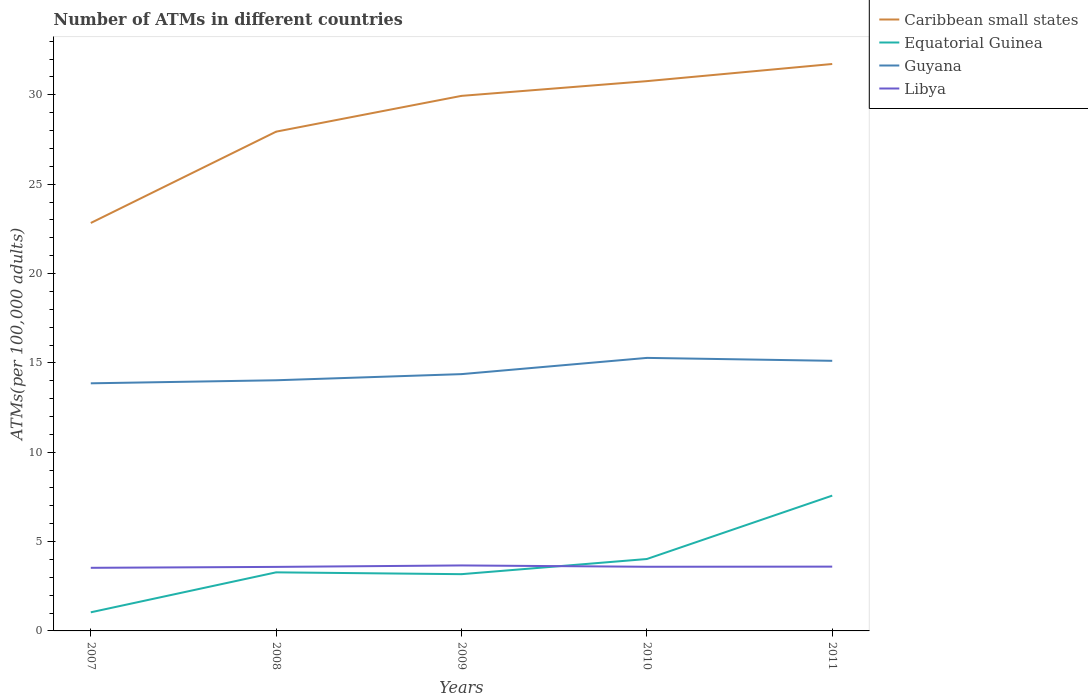How many different coloured lines are there?
Provide a short and direct response. 4. Is the number of lines equal to the number of legend labels?
Your answer should be compact. Yes. Across all years, what is the maximum number of ATMs in Caribbean small states?
Offer a terse response. 22.83. What is the total number of ATMs in Caribbean small states in the graph?
Your answer should be very brief. -8.9. What is the difference between the highest and the second highest number of ATMs in Guyana?
Keep it short and to the point. 1.42. What is the title of the graph?
Ensure brevity in your answer.  Number of ATMs in different countries. What is the label or title of the Y-axis?
Keep it short and to the point. ATMs(per 100,0 adults). What is the ATMs(per 100,000 adults) of Caribbean small states in 2007?
Ensure brevity in your answer.  22.83. What is the ATMs(per 100,000 adults) in Equatorial Guinea in 2007?
Give a very brief answer. 1.04. What is the ATMs(per 100,000 adults) in Guyana in 2007?
Offer a very short reply. 13.86. What is the ATMs(per 100,000 adults) in Libya in 2007?
Provide a short and direct response. 3.53. What is the ATMs(per 100,000 adults) of Caribbean small states in 2008?
Your answer should be very brief. 27.94. What is the ATMs(per 100,000 adults) of Equatorial Guinea in 2008?
Offer a very short reply. 3.28. What is the ATMs(per 100,000 adults) of Guyana in 2008?
Your answer should be very brief. 14.03. What is the ATMs(per 100,000 adults) of Libya in 2008?
Keep it short and to the point. 3.58. What is the ATMs(per 100,000 adults) in Caribbean small states in 2009?
Provide a succinct answer. 29.94. What is the ATMs(per 100,000 adults) in Equatorial Guinea in 2009?
Your answer should be very brief. 3.18. What is the ATMs(per 100,000 adults) in Guyana in 2009?
Your answer should be very brief. 14.37. What is the ATMs(per 100,000 adults) of Libya in 2009?
Ensure brevity in your answer.  3.66. What is the ATMs(per 100,000 adults) of Caribbean small states in 2010?
Provide a short and direct response. 30.77. What is the ATMs(per 100,000 adults) of Equatorial Guinea in 2010?
Make the answer very short. 4.02. What is the ATMs(per 100,000 adults) of Guyana in 2010?
Give a very brief answer. 15.28. What is the ATMs(per 100,000 adults) of Libya in 2010?
Provide a short and direct response. 3.59. What is the ATMs(per 100,000 adults) in Caribbean small states in 2011?
Your response must be concise. 31.73. What is the ATMs(per 100,000 adults) in Equatorial Guinea in 2011?
Your answer should be compact. 7.57. What is the ATMs(per 100,000 adults) of Guyana in 2011?
Give a very brief answer. 15.12. What is the ATMs(per 100,000 adults) of Libya in 2011?
Your answer should be compact. 3.6. Across all years, what is the maximum ATMs(per 100,000 adults) of Caribbean small states?
Provide a succinct answer. 31.73. Across all years, what is the maximum ATMs(per 100,000 adults) of Equatorial Guinea?
Ensure brevity in your answer.  7.57. Across all years, what is the maximum ATMs(per 100,000 adults) of Guyana?
Your answer should be very brief. 15.28. Across all years, what is the maximum ATMs(per 100,000 adults) of Libya?
Offer a terse response. 3.66. Across all years, what is the minimum ATMs(per 100,000 adults) of Caribbean small states?
Your answer should be very brief. 22.83. Across all years, what is the minimum ATMs(per 100,000 adults) of Equatorial Guinea?
Provide a succinct answer. 1.04. Across all years, what is the minimum ATMs(per 100,000 adults) in Guyana?
Keep it short and to the point. 13.86. Across all years, what is the minimum ATMs(per 100,000 adults) of Libya?
Your response must be concise. 3.53. What is the total ATMs(per 100,000 adults) in Caribbean small states in the graph?
Offer a very short reply. 143.21. What is the total ATMs(per 100,000 adults) in Equatorial Guinea in the graph?
Provide a succinct answer. 19.09. What is the total ATMs(per 100,000 adults) in Guyana in the graph?
Your answer should be compact. 72.65. What is the total ATMs(per 100,000 adults) of Libya in the graph?
Offer a very short reply. 17.97. What is the difference between the ATMs(per 100,000 adults) of Caribbean small states in 2007 and that in 2008?
Your response must be concise. -5.11. What is the difference between the ATMs(per 100,000 adults) in Equatorial Guinea in 2007 and that in 2008?
Your response must be concise. -2.24. What is the difference between the ATMs(per 100,000 adults) of Guyana in 2007 and that in 2008?
Offer a terse response. -0.17. What is the difference between the ATMs(per 100,000 adults) of Libya in 2007 and that in 2008?
Provide a succinct answer. -0.05. What is the difference between the ATMs(per 100,000 adults) in Caribbean small states in 2007 and that in 2009?
Provide a short and direct response. -7.11. What is the difference between the ATMs(per 100,000 adults) in Equatorial Guinea in 2007 and that in 2009?
Your answer should be compact. -2.13. What is the difference between the ATMs(per 100,000 adults) in Guyana in 2007 and that in 2009?
Make the answer very short. -0.51. What is the difference between the ATMs(per 100,000 adults) in Libya in 2007 and that in 2009?
Ensure brevity in your answer.  -0.13. What is the difference between the ATMs(per 100,000 adults) of Caribbean small states in 2007 and that in 2010?
Keep it short and to the point. -7.94. What is the difference between the ATMs(per 100,000 adults) of Equatorial Guinea in 2007 and that in 2010?
Offer a very short reply. -2.98. What is the difference between the ATMs(per 100,000 adults) in Guyana in 2007 and that in 2010?
Provide a succinct answer. -1.42. What is the difference between the ATMs(per 100,000 adults) in Libya in 2007 and that in 2010?
Provide a succinct answer. -0.06. What is the difference between the ATMs(per 100,000 adults) in Caribbean small states in 2007 and that in 2011?
Your response must be concise. -8.9. What is the difference between the ATMs(per 100,000 adults) of Equatorial Guinea in 2007 and that in 2011?
Give a very brief answer. -6.53. What is the difference between the ATMs(per 100,000 adults) in Guyana in 2007 and that in 2011?
Keep it short and to the point. -1.26. What is the difference between the ATMs(per 100,000 adults) in Libya in 2007 and that in 2011?
Your answer should be compact. -0.07. What is the difference between the ATMs(per 100,000 adults) of Caribbean small states in 2008 and that in 2009?
Your answer should be very brief. -2. What is the difference between the ATMs(per 100,000 adults) of Equatorial Guinea in 2008 and that in 2009?
Offer a very short reply. 0.1. What is the difference between the ATMs(per 100,000 adults) of Guyana in 2008 and that in 2009?
Offer a very short reply. -0.34. What is the difference between the ATMs(per 100,000 adults) in Libya in 2008 and that in 2009?
Your answer should be very brief. -0.08. What is the difference between the ATMs(per 100,000 adults) in Caribbean small states in 2008 and that in 2010?
Ensure brevity in your answer.  -2.83. What is the difference between the ATMs(per 100,000 adults) of Equatorial Guinea in 2008 and that in 2010?
Offer a very short reply. -0.75. What is the difference between the ATMs(per 100,000 adults) of Guyana in 2008 and that in 2010?
Provide a short and direct response. -1.25. What is the difference between the ATMs(per 100,000 adults) in Libya in 2008 and that in 2010?
Ensure brevity in your answer.  -0.01. What is the difference between the ATMs(per 100,000 adults) of Caribbean small states in 2008 and that in 2011?
Offer a terse response. -3.79. What is the difference between the ATMs(per 100,000 adults) in Equatorial Guinea in 2008 and that in 2011?
Ensure brevity in your answer.  -4.29. What is the difference between the ATMs(per 100,000 adults) of Guyana in 2008 and that in 2011?
Give a very brief answer. -1.09. What is the difference between the ATMs(per 100,000 adults) in Libya in 2008 and that in 2011?
Keep it short and to the point. -0.01. What is the difference between the ATMs(per 100,000 adults) in Caribbean small states in 2009 and that in 2010?
Your answer should be very brief. -0.82. What is the difference between the ATMs(per 100,000 adults) of Equatorial Guinea in 2009 and that in 2010?
Make the answer very short. -0.85. What is the difference between the ATMs(per 100,000 adults) of Guyana in 2009 and that in 2010?
Your answer should be very brief. -0.91. What is the difference between the ATMs(per 100,000 adults) of Libya in 2009 and that in 2010?
Offer a very short reply. 0.07. What is the difference between the ATMs(per 100,000 adults) of Caribbean small states in 2009 and that in 2011?
Ensure brevity in your answer.  -1.78. What is the difference between the ATMs(per 100,000 adults) in Equatorial Guinea in 2009 and that in 2011?
Provide a succinct answer. -4.4. What is the difference between the ATMs(per 100,000 adults) of Guyana in 2009 and that in 2011?
Your response must be concise. -0.75. What is the difference between the ATMs(per 100,000 adults) of Libya in 2009 and that in 2011?
Offer a very short reply. 0.07. What is the difference between the ATMs(per 100,000 adults) of Caribbean small states in 2010 and that in 2011?
Ensure brevity in your answer.  -0.96. What is the difference between the ATMs(per 100,000 adults) of Equatorial Guinea in 2010 and that in 2011?
Your response must be concise. -3.55. What is the difference between the ATMs(per 100,000 adults) in Guyana in 2010 and that in 2011?
Provide a short and direct response. 0.16. What is the difference between the ATMs(per 100,000 adults) of Libya in 2010 and that in 2011?
Your response must be concise. -0.01. What is the difference between the ATMs(per 100,000 adults) of Caribbean small states in 2007 and the ATMs(per 100,000 adults) of Equatorial Guinea in 2008?
Your answer should be very brief. 19.55. What is the difference between the ATMs(per 100,000 adults) of Caribbean small states in 2007 and the ATMs(per 100,000 adults) of Guyana in 2008?
Ensure brevity in your answer.  8.8. What is the difference between the ATMs(per 100,000 adults) of Caribbean small states in 2007 and the ATMs(per 100,000 adults) of Libya in 2008?
Make the answer very short. 19.25. What is the difference between the ATMs(per 100,000 adults) of Equatorial Guinea in 2007 and the ATMs(per 100,000 adults) of Guyana in 2008?
Provide a succinct answer. -12.99. What is the difference between the ATMs(per 100,000 adults) in Equatorial Guinea in 2007 and the ATMs(per 100,000 adults) in Libya in 2008?
Offer a terse response. -2.54. What is the difference between the ATMs(per 100,000 adults) in Guyana in 2007 and the ATMs(per 100,000 adults) in Libya in 2008?
Your answer should be very brief. 10.27. What is the difference between the ATMs(per 100,000 adults) in Caribbean small states in 2007 and the ATMs(per 100,000 adults) in Equatorial Guinea in 2009?
Offer a very short reply. 19.65. What is the difference between the ATMs(per 100,000 adults) in Caribbean small states in 2007 and the ATMs(per 100,000 adults) in Guyana in 2009?
Provide a short and direct response. 8.46. What is the difference between the ATMs(per 100,000 adults) in Caribbean small states in 2007 and the ATMs(per 100,000 adults) in Libya in 2009?
Keep it short and to the point. 19.16. What is the difference between the ATMs(per 100,000 adults) of Equatorial Guinea in 2007 and the ATMs(per 100,000 adults) of Guyana in 2009?
Offer a very short reply. -13.33. What is the difference between the ATMs(per 100,000 adults) of Equatorial Guinea in 2007 and the ATMs(per 100,000 adults) of Libya in 2009?
Offer a terse response. -2.62. What is the difference between the ATMs(per 100,000 adults) of Guyana in 2007 and the ATMs(per 100,000 adults) of Libya in 2009?
Make the answer very short. 10.19. What is the difference between the ATMs(per 100,000 adults) in Caribbean small states in 2007 and the ATMs(per 100,000 adults) in Equatorial Guinea in 2010?
Ensure brevity in your answer.  18.8. What is the difference between the ATMs(per 100,000 adults) of Caribbean small states in 2007 and the ATMs(per 100,000 adults) of Guyana in 2010?
Keep it short and to the point. 7.55. What is the difference between the ATMs(per 100,000 adults) of Caribbean small states in 2007 and the ATMs(per 100,000 adults) of Libya in 2010?
Offer a very short reply. 19.24. What is the difference between the ATMs(per 100,000 adults) in Equatorial Guinea in 2007 and the ATMs(per 100,000 adults) in Guyana in 2010?
Provide a succinct answer. -14.24. What is the difference between the ATMs(per 100,000 adults) of Equatorial Guinea in 2007 and the ATMs(per 100,000 adults) of Libya in 2010?
Offer a terse response. -2.55. What is the difference between the ATMs(per 100,000 adults) in Guyana in 2007 and the ATMs(per 100,000 adults) in Libya in 2010?
Keep it short and to the point. 10.27. What is the difference between the ATMs(per 100,000 adults) in Caribbean small states in 2007 and the ATMs(per 100,000 adults) in Equatorial Guinea in 2011?
Offer a very short reply. 15.26. What is the difference between the ATMs(per 100,000 adults) in Caribbean small states in 2007 and the ATMs(per 100,000 adults) in Guyana in 2011?
Your answer should be compact. 7.71. What is the difference between the ATMs(per 100,000 adults) of Caribbean small states in 2007 and the ATMs(per 100,000 adults) of Libya in 2011?
Give a very brief answer. 19.23. What is the difference between the ATMs(per 100,000 adults) in Equatorial Guinea in 2007 and the ATMs(per 100,000 adults) in Guyana in 2011?
Your response must be concise. -14.07. What is the difference between the ATMs(per 100,000 adults) in Equatorial Guinea in 2007 and the ATMs(per 100,000 adults) in Libya in 2011?
Your answer should be compact. -2.56. What is the difference between the ATMs(per 100,000 adults) of Guyana in 2007 and the ATMs(per 100,000 adults) of Libya in 2011?
Your answer should be compact. 10.26. What is the difference between the ATMs(per 100,000 adults) in Caribbean small states in 2008 and the ATMs(per 100,000 adults) in Equatorial Guinea in 2009?
Provide a short and direct response. 24.76. What is the difference between the ATMs(per 100,000 adults) in Caribbean small states in 2008 and the ATMs(per 100,000 adults) in Guyana in 2009?
Offer a terse response. 13.57. What is the difference between the ATMs(per 100,000 adults) in Caribbean small states in 2008 and the ATMs(per 100,000 adults) in Libya in 2009?
Provide a succinct answer. 24.28. What is the difference between the ATMs(per 100,000 adults) in Equatorial Guinea in 2008 and the ATMs(per 100,000 adults) in Guyana in 2009?
Ensure brevity in your answer.  -11.09. What is the difference between the ATMs(per 100,000 adults) of Equatorial Guinea in 2008 and the ATMs(per 100,000 adults) of Libya in 2009?
Make the answer very short. -0.39. What is the difference between the ATMs(per 100,000 adults) in Guyana in 2008 and the ATMs(per 100,000 adults) in Libya in 2009?
Make the answer very short. 10.36. What is the difference between the ATMs(per 100,000 adults) in Caribbean small states in 2008 and the ATMs(per 100,000 adults) in Equatorial Guinea in 2010?
Provide a short and direct response. 23.92. What is the difference between the ATMs(per 100,000 adults) in Caribbean small states in 2008 and the ATMs(per 100,000 adults) in Guyana in 2010?
Provide a short and direct response. 12.66. What is the difference between the ATMs(per 100,000 adults) of Caribbean small states in 2008 and the ATMs(per 100,000 adults) of Libya in 2010?
Your answer should be very brief. 24.35. What is the difference between the ATMs(per 100,000 adults) of Equatorial Guinea in 2008 and the ATMs(per 100,000 adults) of Guyana in 2010?
Give a very brief answer. -12. What is the difference between the ATMs(per 100,000 adults) in Equatorial Guinea in 2008 and the ATMs(per 100,000 adults) in Libya in 2010?
Offer a terse response. -0.31. What is the difference between the ATMs(per 100,000 adults) of Guyana in 2008 and the ATMs(per 100,000 adults) of Libya in 2010?
Give a very brief answer. 10.44. What is the difference between the ATMs(per 100,000 adults) in Caribbean small states in 2008 and the ATMs(per 100,000 adults) in Equatorial Guinea in 2011?
Your answer should be very brief. 20.37. What is the difference between the ATMs(per 100,000 adults) in Caribbean small states in 2008 and the ATMs(per 100,000 adults) in Guyana in 2011?
Keep it short and to the point. 12.82. What is the difference between the ATMs(per 100,000 adults) of Caribbean small states in 2008 and the ATMs(per 100,000 adults) of Libya in 2011?
Your response must be concise. 24.34. What is the difference between the ATMs(per 100,000 adults) in Equatorial Guinea in 2008 and the ATMs(per 100,000 adults) in Guyana in 2011?
Provide a short and direct response. -11.84. What is the difference between the ATMs(per 100,000 adults) in Equatorial Guinea in 2008 and the ATMs(per 100,000 adults) in Libya in 2011?
Keep it short and to the point. -0.32. What is the difference between the ATMs(per 100,000 adults) of Guyana in 2008 and the ATMs(per 100,000 adults) of Libya in 2011?
Offer a terse response. 10.43. What is the difference between the ATMs(per 100,000 adults) in Caribbean small states in 2009 and the ATMs(per 100,000 adults) in Equatorial Guinea in 2010?
Provide a succinct answer. 25.92. What is the difference between the ATMs(per 100,000 adults) in Caribbean small states in 2009 and the ATMs(per 100,000 adults) in Guyana in 2010?
Provide a succinct answer. 14.66. What is the difference between the ATMs(per 100,000 adults) in Caribbean small states in 2009 and the ATMs(per 100,000 adults) in Libya in 2010?
Your answer should be very brief. 26.35. What is the difference between the ATMs(per 100,000 adults) of Equatorial Guinea in 2009 and the ATMs(per 100,000 adults) of Guyana in 2010?
Keep it short and to the point. -12.1. What is the difference between the ATMs(per 100,000 adults) in Equatorial Guinea in 2009 and the ATMs(per 100,000 adults) in Libya in 2010?
Your answer should be compact. -0.41. What is the difference between the ATMs(per 100,000 adults) in Guyana in 2009 and the ATMs(per 100,000 adults) in Libya in 2010?
Ensure brevity in your answer.  10.78. What is the difference between the ATMs(per 100,000 adults) in Caribbean small states in 2009 and the ATMs(per 100,000 adults) in Equatorial Guinea in 2011?
Your answer should be compact. 22.37. What is the difference between the ATMs(per 100,000 adults) of Caribbean small states in 2009 and the ATMs(per 100,000 adults) of Guyana in 2011?
Give a very brief answer. 14.83. What is the difference between the ATMs(per 100,000 adults) in Caribbean small states in 2009 and the ATMs(per 100,000 adults) in Libya in 2011?
Provide a short and direct response. 26.34. What is the difference between the ATMs(per 100,000 adults) of Equatorial Guinea in 2009 and the ATMs(per 100,000 adults) of Guyana in 2011?
Keep it short and to the point. -11.94. What is the difference between the ATMs(per 100,000 adults) of Equatorial Guinea in 2009 and the ATMs(per 100,000 adults) of Libya in 2011?
Make the answer very short. -0.42. What is the difference between the ATMs(per 100,000 adults) of Guyana in 2009 and the ATMs(per 100,000 adults) of Libya in 2011?
Your answer should be compact. 10.77. What is the difference between the ATMs(per 100,000 adults) of Caribbean small states in 2010 and the ATMs(per 100,000 adults) of Equatorial Guinea in 2011?
Your answer should be very brief. 23.2. What is the difference between the ATMs(per 100,000 adults) of Caribbean small states in 2010 and the ATMs(per 100,000 adults) of Guyana in 2011?
Keep it short and to the point. 15.65. What is the difference between the ATMs(per 100,000 adults) in Caribbean small states in 2010 and the ATMs(per 100,000 adults) in Libya in 2011?
Ensure brevity in your answer.  27.17. What is the difference between the ATMs(per 100,000 adults) of Equatorial Guinea in 2010 and the ATMs(per 100,000 adults) of Guyana in 2011?
Ensure brevity in your answer.  -11.09. What is the difference between the ATMs(per 100,000 adults) of Equatorial Guinea in 2010 and the ATMs(per 100,000 adults) of Libya in 2011?
Your answer should be compact. 0.43. What is the difference between the ATMs(per 100,000 adults) of Guyana in 2010 and the ATMs(per 100,000 adults) of Libya in 2011?
Your answer should be very brief. 11.68. What is the average ATMs(per 100,000 adults) in Caribbean small states per year?
Your response must be concise. 28.64. What is the average ATMs(per 100,000 adults) in Equatorial Guinea per year?
Make the answer very short. 3.82. What is the average ATMs(per 100,000 adults) of Guyana per year?
Ensure brevity in your answer.  14.53. What is the average ATMs(per 100,000 adults) of Libya per year?
Your answer should be compact. 3.59. In the year 2007, what is the difference between the ATMs(per 100,000 adults) in Caribbean small states and ATMs(per 100,000 adults) in Equatorial Guinea?
Offer a terse response. 21.79. In the year 2007, what is the difference between the ATMs(per 100,000 adults) in Caribbean small states and ATMs(per 100,000 adults) in Guyana?
Provide a succinct answer. 8.97. In the year 2007, what is the difference between the ATMs(per 100,000 adults) in Caribbean small states and ATMs(per 100,000 adults) in Libya?
Offer a terse response. 19.3. In the year 2007, what is the difference between the ATMs(per 100,000 adults) of Equatorial Guinea and ATMs(per 100,000 adults) of Guyana?
Provide a short and direct response. -12.81. In the year 2007, what is the difference between the ATMs(per 100,000 adults) in Equatorial Guinea and ATMs(per 100,000 adults) in Libya?
Your response must be concise. -2.49. In the year 2007, what is the difference between the ATMs(per 100,000 adults) of Guyana and ATMs(per 100,000 adults) of Libya?
Provide a succinct answer. 10.33. In the year 2008, what is the difference between the ATMs(per 100,000 adults) in Caribbean small states and ATMs(per 100,000 adults) in Equatorial Guinea?
Offer a terse response. 24.66. In the year 2008, what is the difference between the ATMs(per 100,000 adults) of Caribbean small states and ATMs(per 100,000 adults) of Guyana?
Your answer should be compact. 13.91. In the year 2008, what is the difference between the ATMs(per 100,000 adults) of Caribbean small states and ATMs(per 100,000 adults) of Libya?
Make the answer very short. 24.36. In the year 2008, what is the difference between the ATMs(per 100,000 adults) of Equatorial Guinea and ATMs(per 100,000 adults) of Guyana?
Keep it short and to the point. -10.75. In the year 2008, what is the difference between the ATMs(per 100,000 adults) in Equatorial Guinea and ATMs(per 100,000 adults) in Libya?
Give a very brief answer. -0.3. In the year 2008, what is the difference between the ATMs(per 100,000 adults) of Guyana and ATMs(per 100,000 adults) of Libya?
Provide a short and direct response. 10.44. In the year 2009, what is the difference between the ATMs(per 100,000 adults) of Caribbean small states and ATMs(per 100,000 adults) of Equatorial Guinea?
Offer a terse response. 26.77. In the year 2009, what is the difference between the ATMs(per 100,000 adults) of Caribbean small states and ATMs(per 100,000 adults) of Guyana?
Give a very brief answer. 15.57. In the year 2009, what is the difference between the ATMs(per 100,000 adults) of Caribbean small states and ATMs(per 100,000 adults) of Libya?
Your answer should be very brief. 26.28. In the year 2009, what is the difference between the ATMs(per 100,000 adults) in Equatorial Guinea and ATMs(per 100,000 adults) in Guyana?
Provide a short and direct response. -11.19. In the year 2009, what is the difference between the ATMs(per 100,000 adults) of Equatorial Guinea and ATMs(per 100,000 adults) of Libya?
Your response must be concise. -0.49. In the year 2009, what is the difference between the ATMs(per 100,000 adults) of Guyana and ATMs(per 100,000 adults) of Libya?
Give a very brief answer. 10.71. In the year 2010, what is the difference between the ATMs(per 100,000 adults) in Caribbean small states and ATMs(per 100,000 adults) in Equatorial Guinea?
Offer a terse response. 26.74. In the year 2010, what is the difference between the ATMs(per 100,000 adults) of Caribbean small states and ATMs(per 100,000 adults) of Guyana?
Provide a succinct answer. 15.49. In the year 2010, what is the difference between the ATMs(per 100,000 adults) of Caribbean small states and ATMs(per 100,000 adults) of Libya?
Your response must be concise. 27.18. In the year 2010, what is the difference between the ATMs(per 100,000 adults) of Equatorial Guinea and ATMs(per 100,000 adults) of Guyana?
Your answer should be very brief. -11.25. In the year 2010, what is the difference between the ATMs(per 100,000 adults) in Equatorial Guinea and ATMs(per 100,000 adults) in Libya?
Provide a succinct answer. 0.43. In the year 2010, what is the difference between the ATMs(per 100,000 adults) in Guyana and ATMs(per 100,000 adults) in Libya?
Provide a short and direct response. 11.69. In the year 2011, what is the difference between the ATMs(per 100,000 adults) of Caribbean small states and ATMs(per 100,000 adults) of Equatorial Guinea?
Provide a succinct answer. 24.16. In the year 2011, what is the difference between the ATMs(per 100,000 adults) of Caribbean small states and ATMs(per 100,000 adults) of Guyana?
Keep it short and to the point. 16.61. In the year 2011, what is the difference between the ATMs(per 100,000 adults) in Caribbean small states and ATMs(per 100,000 adults) in Libya?
Ensure brevity in your answer.  28.13. In the year 2011, what is the difference between the ATMs(per 100,000 adults) of Equatorial Guinea and ATMs(per 100,000 adults) of Guyana?
Offer a very short reply. -7.54. In the year 2011, what is the difference between the ATMs(per 100,000 adults) of Equatorial Guinea and ATMs(per 100,000 adults) of Libya?
Your response must be concise. 3.97. In the year 2011, what is the difference between the ATMs(per 100,000 adults) of Guyana and ATMs(per 100,000 adults) of Libya?
Your answer should be compact. 11.52. What is the ratio of the ATMs(per 100,000 adults) of Caribbean small states in 2007 to that in 2008?
Make the answer very short. 0.82. What is the ratio of the ATMs(per 100,000 adults) in Equatorial Guinea in 2007 to that in 2008?
Provide a succinct answer. 0.32. What is the ratio of the ATMs(per 100,000 adults) of Libya in 2007 to that in 2008?
Your answer should be very brief. 0.99. What is the ratio of the ATMs(per 100,000 adults) of Caribbean small states in 2007 to that in 2009?
Ensure brevity in your answer.  0.76. What is the ratio of the ATMs(per 100,000 adults) in Equatorial Guinea in 2007 to that in 2009?
Provide a short and direct response. 0.33. What is the ratio of the ATMs(per 100,000 adults) of Guyana in 2007 to that in 2009?
Make the answer very short. 0.96. What is the ratio of the ATMs(per 100,000 adults) in Libya in 2007 to that in 2009?
Your answer should be very brief. 0.96. What is the ratio of the ATMs(per 100,000 adults) in Caribbean small states in 2007 to that in 2010?
Keep it short and to the point. 0.74. What is the ratio of the ATMs(per 100,000 adults) of Equatorial Guinea in 2007 to that in 2010?
Keep it short and to the point. 0.26. What is the ratio of the ATMs(per 100,000 adults) in Guyana in 2007 to that in 2010?
Ensure brevity in your answer.  0.91. What is the ratio of the ATMs(per 100,000 adults) in Libya in 2007 to that in 2010?
Keep it short and to the point. 0.98. What is the ratio of the ATMs(per 100,000 adults) in Caribbean small states in 2007 to that in 2011?
Provide a short and direct response. 0.72. What is the ratio of the ATMs(per 100,000 adults) in Equatorial Guinea in 2007 to that in 2011?
Give a very brief answer. 0.14. What is the ratio of the ATMs(per 100,000 adults) in Guyana in 2007 to that in 2011?
Offer a terse response. 0.92. What is the ratio of the ATMs(per 100,000 adults) of Libya in 2007 to that in 2011?
Provide a short and direct response. 0.98. What is the ratio of the ATMs(per 100,000 adults) of Caribbean small states in 2008 to that in 2009?
Your answer should be compact. 0.93. What is the ratio of the ATMs(per 100,000 adults) in Equatorial Guinea in 2008 to that in 2009?
Your response must be concise. 1.03. What is the ratio of the ATMs(per 100,000 adults) in Guyana in 2008 to that in 2009?
Your response must be concise. 0.98. What is the ratio of the ATMs(per 100,000 adults) of Libya in 2008 to that in 2009?
Make the answer very short. 0.98. What is the ratio of the ATMs(per 100,000 adults) of Caribbean small states in 2008 to that in 2010?
Your answer should be compact. 0.91. What is the ratio of the ATMs(per 100,000 adults) of Equatorial Guinea in 2008 to that in 2010?
Provide a short and direct response. 0.81. What is the ratio of the ATMs(per 100,000 adults) of Guyana in 2008 to that in 2010?
Your answer should be compact. 0.92. What is the ratio of the ATMs(per 100,000 adults) of Caribbean small states in 2008 to that in 2011?
Offer a terse response. 0.88. What is the ratio of the ATMs(per 100,000 adults) in Equatorial Guinea in 2008 to that in 2011?
Ensure brevity in your answer.  0.43. What is the ratio of the ATMs(per 100,000 adults) in Guyana in 2008 to that in 2011?
Offer a terse response. 0.93. What is the ratio of the ATMs(per 100,000 adults) in Libya in 2008 to that in 2011?
Provide a short and direct response. 1. What is the ratio of the ATMs(per 100,000 adults) of Caribbean small states in 2009 to that in 2010?
Offer a terse response. 0.97. What is the ratio of the ATMs(per 100,000 adults) of Equatorial Guinea in 2009 to that in 2010?
Your answer should be very brief. 0.79. What is the ratio of the ATMs(per 100,000 adults) of Guyana in 2009 to that in 2010?
Ensure brevity in your answer.  0.94. What is the ratio of the ATMs(per 100,000 adults) of Libya in 2009 to that in 2010?
Your answer should be very brief. 1.02. What is the ratio of the ATMs(per 100,000 adults) of Caribbean small states in 2009 to that in 2011?
Offer a terse response. 0.94. What is the ratio of the ATMs(per 100,000 adults) of Equatorial Guinea in 2009 to that in 2011?
Offer a terse response. 0.42. What is the ratio of the ATMs(per 100,000 adults) of Guyana in 2009 to that in 2011?
Keep it short and to the point. 0.95. What is the ratio of the ATMs(per 100,000 adults) of Libya in 2009 to that in 2011?
Ensure brevity in your answer.  1.02. What is the ratio of the ATMs(per 100,000 adults) of Caribbean small states in 2010 to that in 2011?
Offer a terse response. 0.97. What is the ratio of the ATMs(per 100,000 adults) in Equatorial Guinea in 2010 to that in 2011?
Your answer should be very brief. 0.53. What is the ratio of the ATMs(per 100,000 adults) in Guyana in 2010 to that in 2011?
Provide a succinct answer. 1.01. What is the difference between the highest and the second highest ATMs(per 100,000 adults) of Caribbean small states?
Your response must be concise. 0.96. What is the difference between the highest and the second highest ATMs(per 100,000 adults) of Equatorial Guinea?
Provide a succinct answer. 3.55. What is the difference between the highest and the second highest ATMs(per 100,000 adults) of Guyana?
Your response must be concise. 0.16. What is the difference between the highest and the second highest ATMs(per 100,000 adults) of Libya?
Keep it short and to the point. 0.07. What is the difference between the highest and the lowest ATMs(per 100,000 adults) of Caribbean small states?
Ensure brevity in your answer.  8.9. What is the difference between the highest and the lowest ATMs(per 100,000 adults) in Equatorial Guinea?
Your response must be concise. 6.53. What is the difference between the highest and the lowest ATMs(per 100,000 adults) of Guyana?
Your answer should be compact. 1.42. What is the difference between the highest and the lowest ATMs(per 100,000 adults) in Libya?
Make the answer very short. 0.13. 